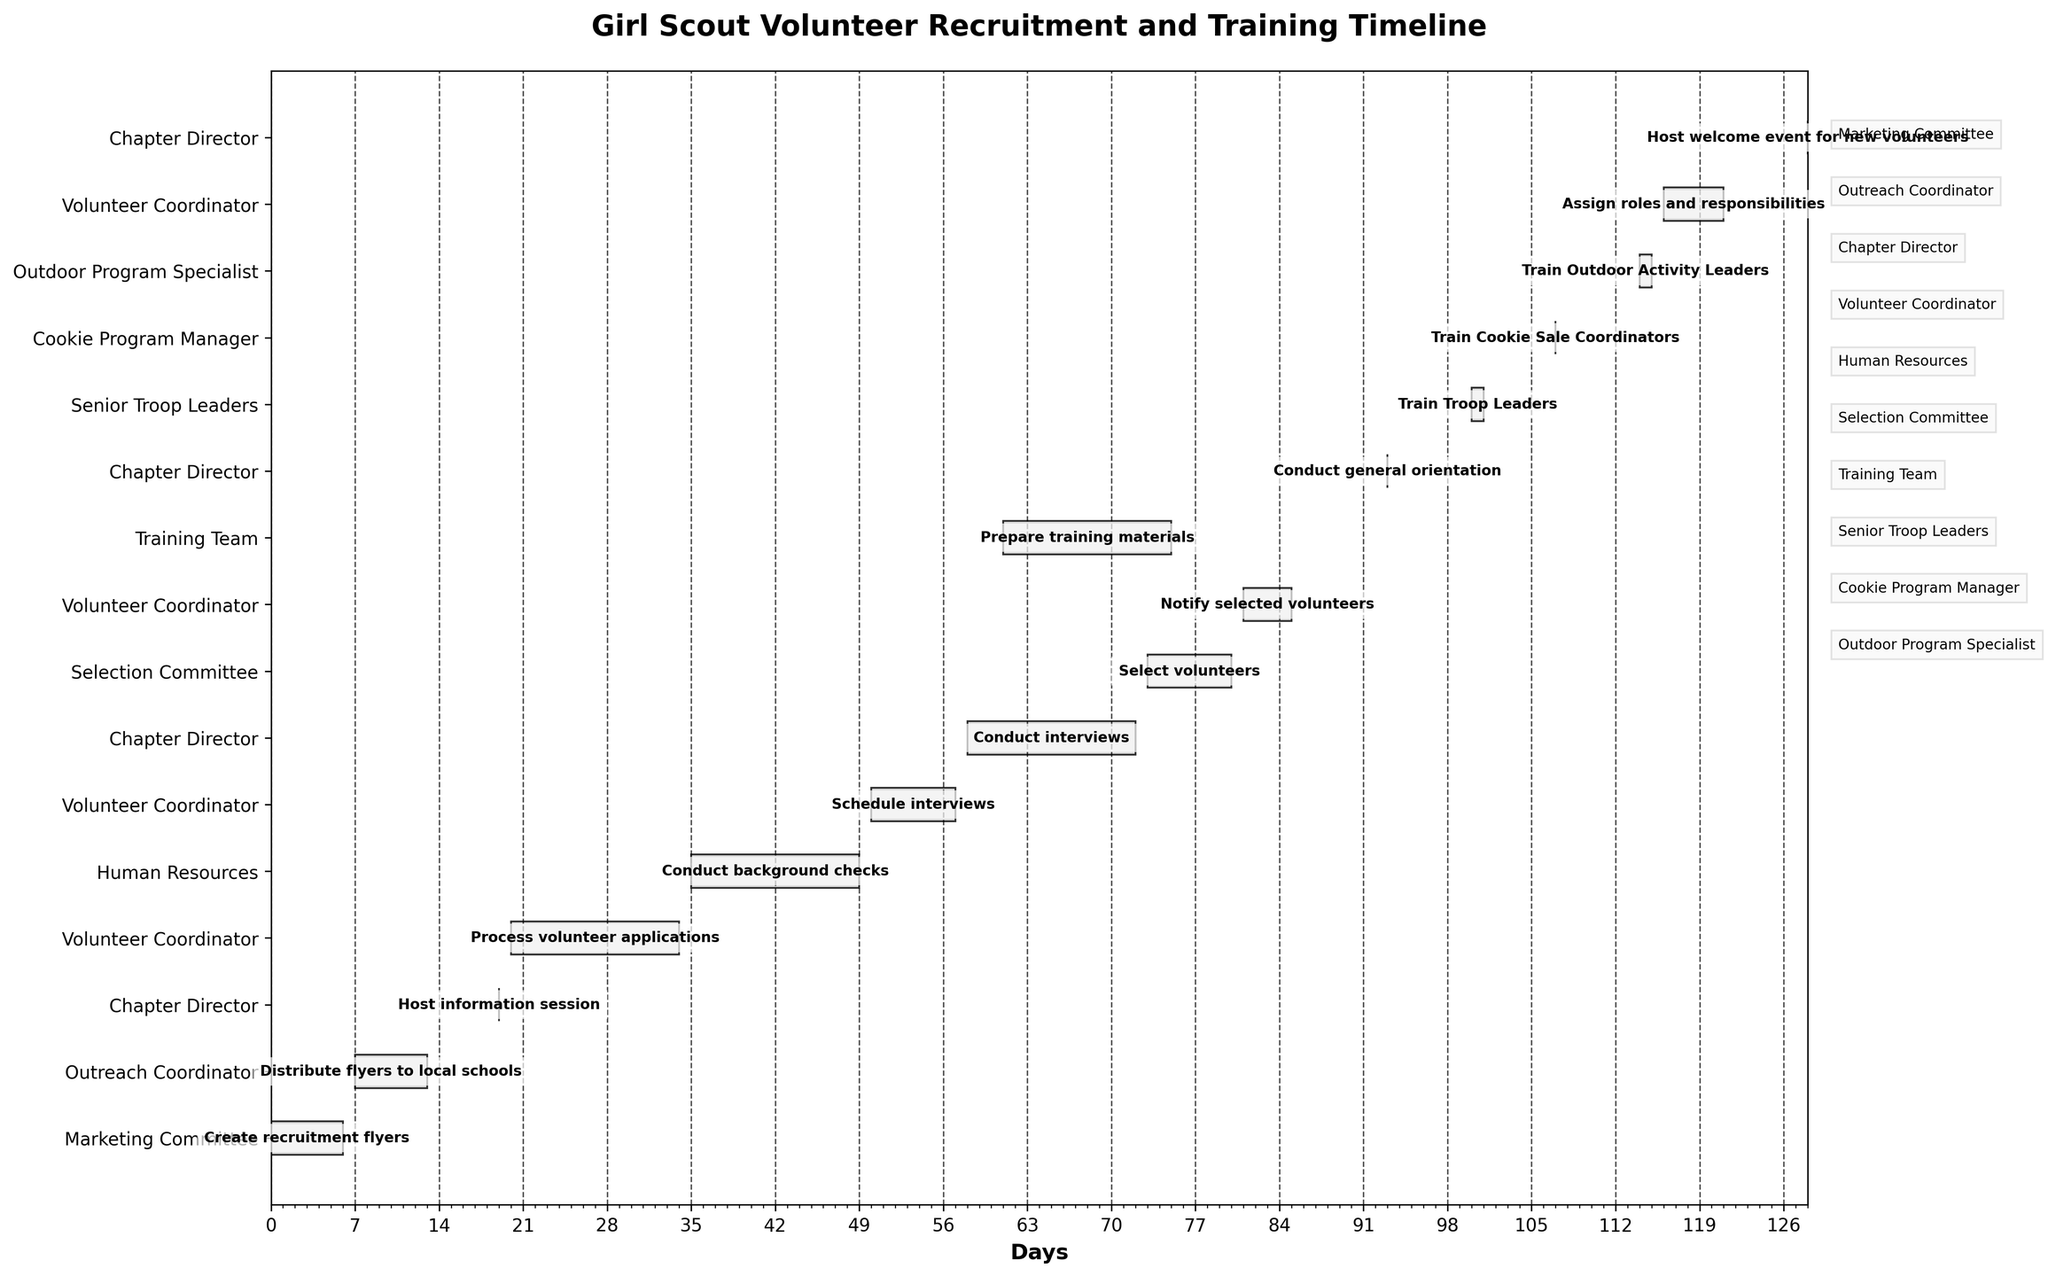How many tasks are scheduled for the Volunteer Coordinator? Count the number of tasks in the "Volunteer Coordinator" row. The bar lengths and positions show the tasks associated with the role.
Answer: 4 What is the total duration of the "Create recruitment flyers" task? Look for the "Create recruitment flyers" bar and note its length, labelled with the duration.
Answer: 7 days When does the "Train Cookie Sale Coordinators" task occur? Identify the "Train Cookie Sale Coordinators" task by finding its label. The x-axis points to the specific date.
Answer: 2023-09-16 Which role is responsible for the greatest number of tasks? Compare the number of tasks (bars) for each responsible role on the y-axis.
Answer: Chapter Director What is the duration of the project from the first to the last task? Calculate the difference in days between the start of the first task ("Create recruitment flyers" starting on 2023-06-01) and the end of the last task ("Host welcome event for new volunteers" ending on 2023-10-07) by referring to the x-axis.
Answer: 129 days How many tasks are directly overseen by the Chapter Director? Check for bars labelled with the Chapter Director's responsibilities. Count the number of tasks on the y-axis labelled for "Chapter Director".
Answer: 4 Which task starts immediately after the "Conduct background checks"? Locate "Conduct background checks" on the y-axis and the Gantt bars, then find the next task starting after its end date (2023-07-20).
Answer: Schedule interviews How long after starting the "Prepare training materials" task will the "Notify selected volunteers" task begin? Note the start dates of "Prepare training materials" (2023-08-01) and "Notify selected volunteers" (2023-08-21), and calculate the difference in days between these two dates.
Answer: 20 days What is the average duration of tasks handled by the Training Team? Identify the tasks handled by the Training Team, sum their durations (single task "Prepare training materials" duration is 15 days), and then divide by the number of tasks.
Answer: 15 days Which tasks will the Chapter Director accomplish in a single day? Identify the tasks overseen by the Chapter Director and note their durations. Those lasting a single day should be evident by the short bar lengths and specific start and end dates.
Answer: Host information session, Conduct general orientation, Host welcome event for new volunteers 